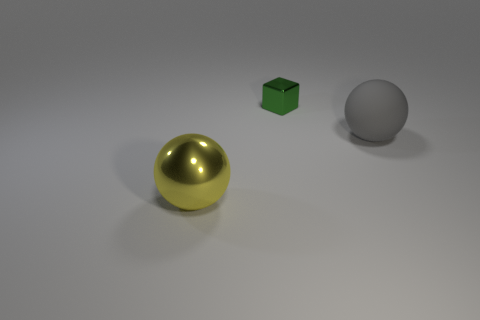Add 2 small brown shiny things. How many objects exist? 5 Subtract all yellow spheres. How many spheres are left? 1 Subtract all spheres. How many objects are left? 1 Subtract 1 spheres. How many spheres are left? 1 Subtract all red cubes. Subtract all brown spheres. How many cubes are left? 1 Subtract all large purple matte cylinders. Subtract all big gray rubber things. How many objects are left? 2 Add 3 small metallic cubes. How many small metallic cubes are left? 4 Add 1 big rubber things. How many big rubber things exist? 2 Subtract 0 yellow cubes. How many objects are left? 3 